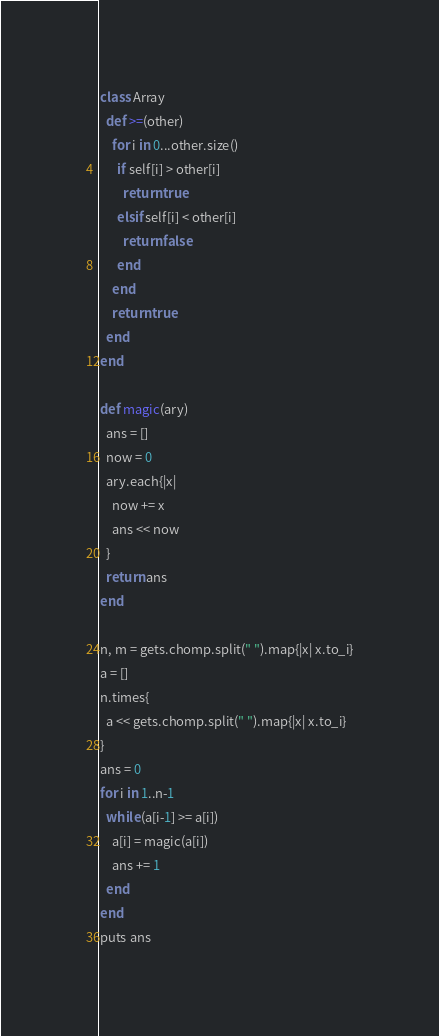Convert code to text. <code><loc_0><loc_0><loc_500><loc_500><_Ruby_>class Array
  def >=(other)
    for i in 0...other.size()
      if self[i] > other[i]
        return true
      elsif self[i] < other[i]
        return false
      end
    end
    return true
  end
end

def magic(ary)
  ans = []
  now = 0
  ary.each{|x|
    now += x
    ans << now
  }
  return ans
end

n, m = gets.chomp.split(" ").map{|x| x.to_i}
a = []
n.times{
  a << gets.chomp.split(" ").map{|x| x.to_i}
}
ans = 0
for i in 1..n-1
  while (a[i-1] >= a[i])
    a[i] = magic(a[i])
    ans += 1
  end
end
puts ans

</code> 